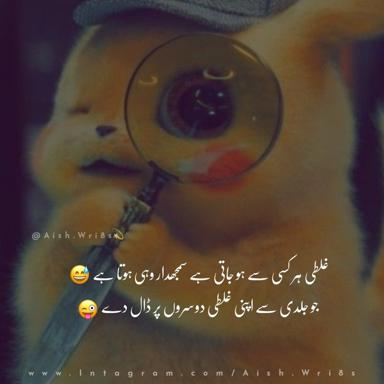How might this type of themed hat with a magnifying glass be used at a themed party or convention? This themed Pikachu hat with a magnifying glass could be a hit at a themed party or convention, particularly those focusing on anime, Pokemon, or detective themes. Attendees might wear it to embody their favorite character's spirit or evoke a sense of fun and investigation. It could also serve as a conversation starter or a key accessory in cosplay, adding both authenticity and functionality to a costume. 